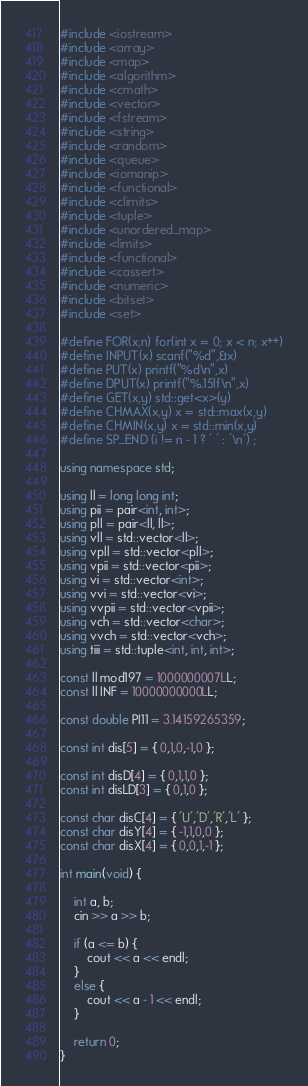<code> <loc_0><loc_0><loc_500><loc_500><_C++_>#include <iostream>
#include <array>
#include <map>
#include <algorithm>
#include <cmath>
#include <vector>
#include <fstream>
#include <string>
#include <random>
#include <queue>
#include <iomanip>
#include <functional>
#include <climits>
#include <tuple>
#include <unordered_map>
#include <limits>
#include <functional>
#include <cassert>
#include <numeric>
#include <bitset>
#include <set>

#define FOR(x,n) for(int x = 0; x < n; x++)
#define INPUT(x) scanf("%d",&x)
#define PUT(x) printf("%d\n",x)
#define DPUT(x) printf("%.15lf\n",x)
#define GET(x,y) std::get<x>(y)
#define CHMAX(x,y) x = std::max(x,y)
#define CHMIN(x,y) x = std::min(x,y)
#define SP_END (i != n - 1 ? ' ' : '\n') ;

using namespace std;

using ll = long long int;
using pii = pair<int, int>;
using pll = pair<ll, ll>;
using vll = std::vector<ll>;
using vpll = std::vector<pll>;
using vpii = std::vector<pii>;
using vi = std::vector<int>;
using vvi = std::vector<vi>;
using vvpii = std::vector<vpii>;
using vch = std::vector<char>;
using vvch = std::vector<vch>;
using tiii = std::tuple<int, int, int>;

const ll mod197 = 1000000007LL;
const ll INF = 10000000000LL;

const double PI11 = 3.14159265359;

const int dis[5] = { 0,1,0,-1,0 };

const int disD[4] = { 0,1,1,0 };
const int disLD[3] = { 0,1,0 };

const char disC[4] = { 'U','D','R','L' };
const char disY[4] = { -1,1,0,0 };
const char disX[4] = { 0,0,1,-1 };

int main(void) {

	int a, b;
	cin >> a >> b;

	if (a <= b) {
		cout << a << endl;
	}
	else {
		cout << a - 1 << endl;
	}

	return 0;
}
</code> 